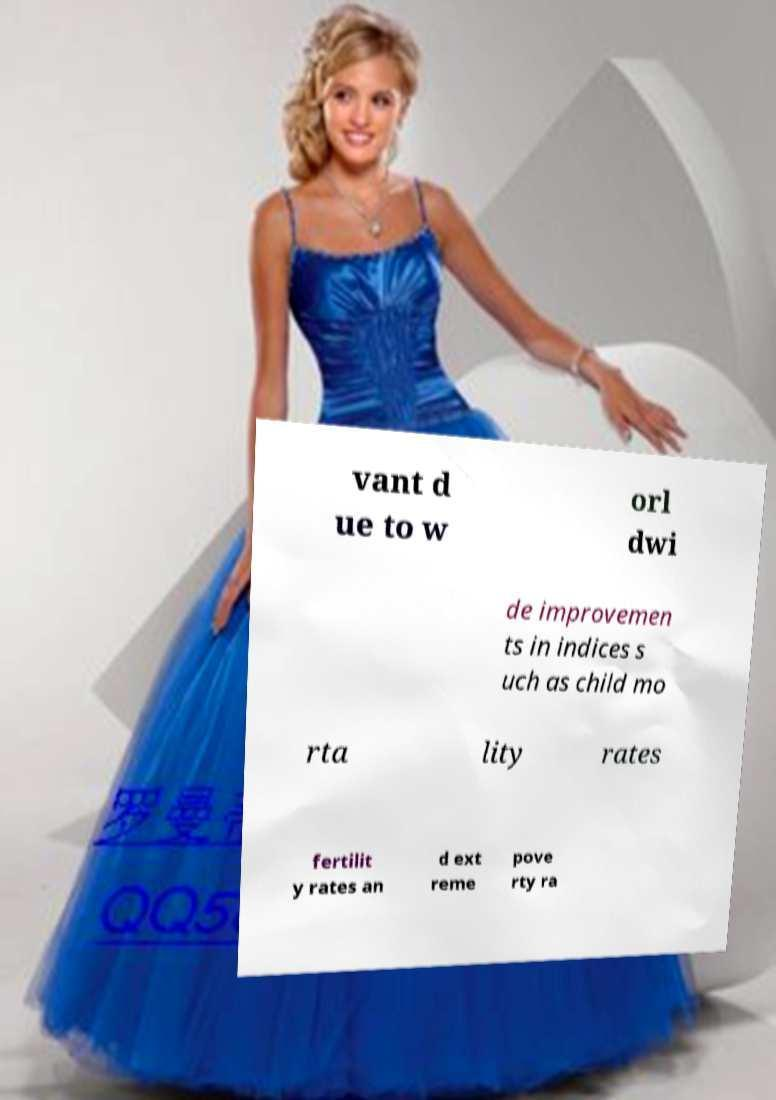There's text embedded in this image that I need extracted. Can you transcribe it verbatim? vant d ue to w orl dwi de improvemen ts in indices s uch as child mo rta lity rates fertilit y rates an d ext reme pove rty ra 